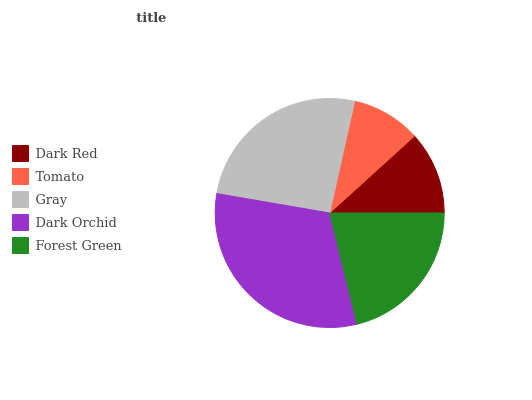Is Tomato the minimum?
Answer yes or no. Yes. Is Dark Orchid the maximum?
Answer yes or no. Yes. Is Gray the minimum?
Answer yes or no. No. Is Gray the maximum?
Answer yes or no. No. Is Gray greater than Tomato?
Answer yes or no. Yes. Is Tomato less than Gray?
Answer yes or no. Yes. Is Tomato greater than Gray?
Answer yes or no. No. Is Gray less than Tomato?
Answer yes or no. No. Is Forest Green the high median?
Answer yes or no. Yes. Is Forest Green the low median?
Answer yes or no. Yes. Is Tomato the high median?
Answer yes or no. No. Is Dark Red the low median?
Answer yes or no. No. 